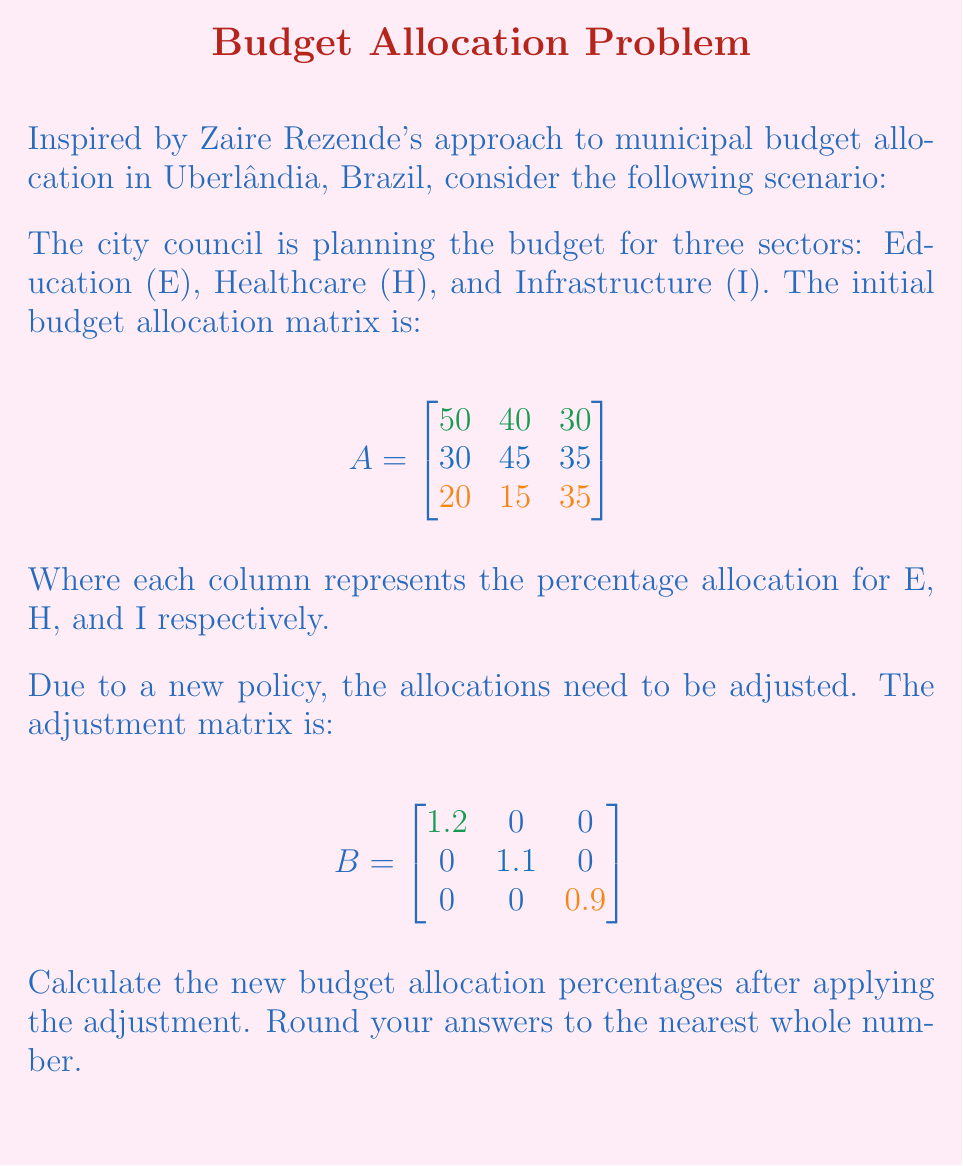Can you solve this math problem? To solve this problem, we need to multiply matrices A and B. This operation will adjust each sector's allocation according to the new policy.

Step 1: Multiply matrices A and B
$$C = A \times B$$

$$C = \begin{bmatrix}
50 & 40 & 30 \\
30 & 45 & 35 \\
20 & 15 & 35
\end{bmatrix} \times
\begin{bmatrix}
1.2 & 0 & 0 \\
0 & 1.1 & 0 \\
0 & 0 & 0.9
\end{bmatrix}$$

Step 2: Perform the matrix multiplication
$$C = \begin{bmatrix}
50 \times 1.2 & 40 \times 1.1 & 30 \times 0.9 \\
30 \times 1.2 & 45 \times 1.1 & 35 \times 0.9 \\
20 \times 1.2 & 15 \times 1.1 & 35 \times 0.9
\end{bmatrix}$$

$$C = \begin{bmatrix}
60 & 44 & 27 \\
36 & 49.5 & 31.5 \\
24 & 16.5 & 31.5
\end{bmatrix}$$

Step 3: Round the results to the nearest whole number
$$C \approx \begin{bmatrix}
60 & 44 & 27 \\
36 & 50 & 32 \\
24 & 17 & 32
\end{bmatrix}$$

The new budget allocation percentages are:
Education: 60%, 36%, 24%
Healthcare: 44%, 50%, 17%
Infrastructure: 27%, 32%, 32%
Answer: $$\begin{bmatrix}
60 & 44 & 27 \\
36 & 50 & 32 \\
24 & 17 & 32
\end{bmatrix}$$ 